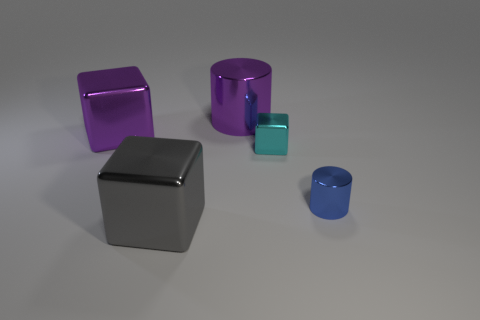There is a object that is the same color as the big cylinder; what is its size?
Provide a short and direct response. Large. What is the shape of the large shiny object that is the same color as the large metal cylinder?
Ensure brevity in your answer.  Cube. There is a object on the left side of the gray metal cube; are there any small blue shiny cylinders that are on the left side of it?
Keep it short and to the point. No. What number of objects are either tiny things that are behind the small blue object or cyan metal cubes?
Offer a very short reply. 1. How many large purple shiny blocks are there?
Provide a succinct answer. 1. What is the shape of the small blue object that is made of the same material as the tiny cyan block?
Provide a succinct answer. Cylinder. There is a purple metallic object that is on the left side of the metallic cylinder behind the cyan block; what is its size?
Your answer should be compact. Large. How many things are either cylinders behind the blue cylinder or shiny things in front of the tiny blue shiny cylinder?
Make the answer very short. 2. Are there fewer small blue metal things than tiny brown objects?
Your answer should be compact. No. What number of objects are either blue metal cylinders or green cubes?
Give a very brief answer. 1. 